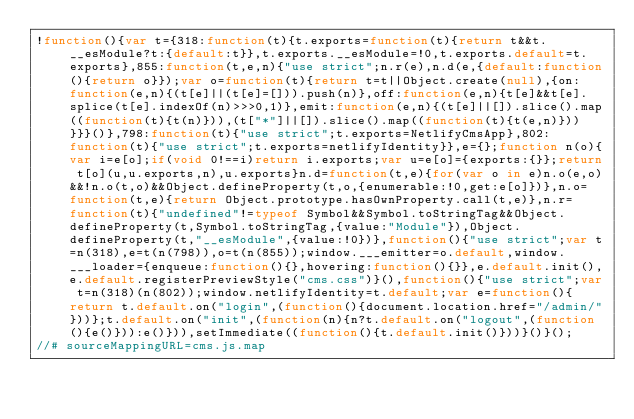Convert code to text. <code><loc_0><loc_0><loc_500><loc_500><_JavaScript_>!function(){var t={318:function(t){t.exports=function(t){return t&&t.__esModule?t:{default:t}},t.exports.__esModule=!0,t.exports.default=t.exports},855:function(t,e,n){"use strict";n.r(e),n.d(e,{default:function(){return o}});var o=function(t){return t=t||Object.create(null),{on:function(e,n){(t[e]||(t[e]=[])).push(n)},off:function(e,n){t[e]&&t[e].splice(t[e].indexOf(n)>>>0,1)},emit:function(e,n){(t[e]||[]).slice().map((function(t){t(n)})),(t["*"]||[]).slice().map((function(t){t(e,n)}))}}}()},798:function(t){"use strict";t.exports=NetlifyCmsApp},802:function(t){"use strict";t.exports=netlifyIdentity}},e={};function n(o){var i=e[o];if(void 0!==i)return i.exports;var u=e[o]={exports:{}};return t[o](u,u.exports,n),u.exports}n.d=function(t,e){for(var o in e)n.o(e,o)&&!n.o(t,o)&&Object.defineProperty(t,o,{enumerable:!0,get:e[o]})},n.o=function(t,e){return Object.prototype.hasOwnProperty.call(t,e)},n.r=function(t){"undefined"!=typeof Symbol&&Symbol.toStringTag&&Object.defineProperty(t,Symbol.toStringTag,{value:"Module"}),Object.defineProperty(t,"__esModule",{value:!0})},function(){"use strict";var t=n(318),e=t(n(798)),o=t(n(855));window.___emitter=o.default,window.___loader={enqueue:function(){},hovering:function(){}},e.default.init(),e.default.registerPreviewStyle("cms.css")}(),function(){"use strict";var t=n(318)(n(802));window.netlifyIdentity=t.default;var e=function(){return t.default.on("login",(function(){document.location.href="/admin/"}))};t.default.on("init",(function(n){n?t.default.on("logout",(function(){e()})):e()})),setImmediate((function(){t.default.init()}))}()}();
//# sourceMappingURL=cms.js.map</code> 